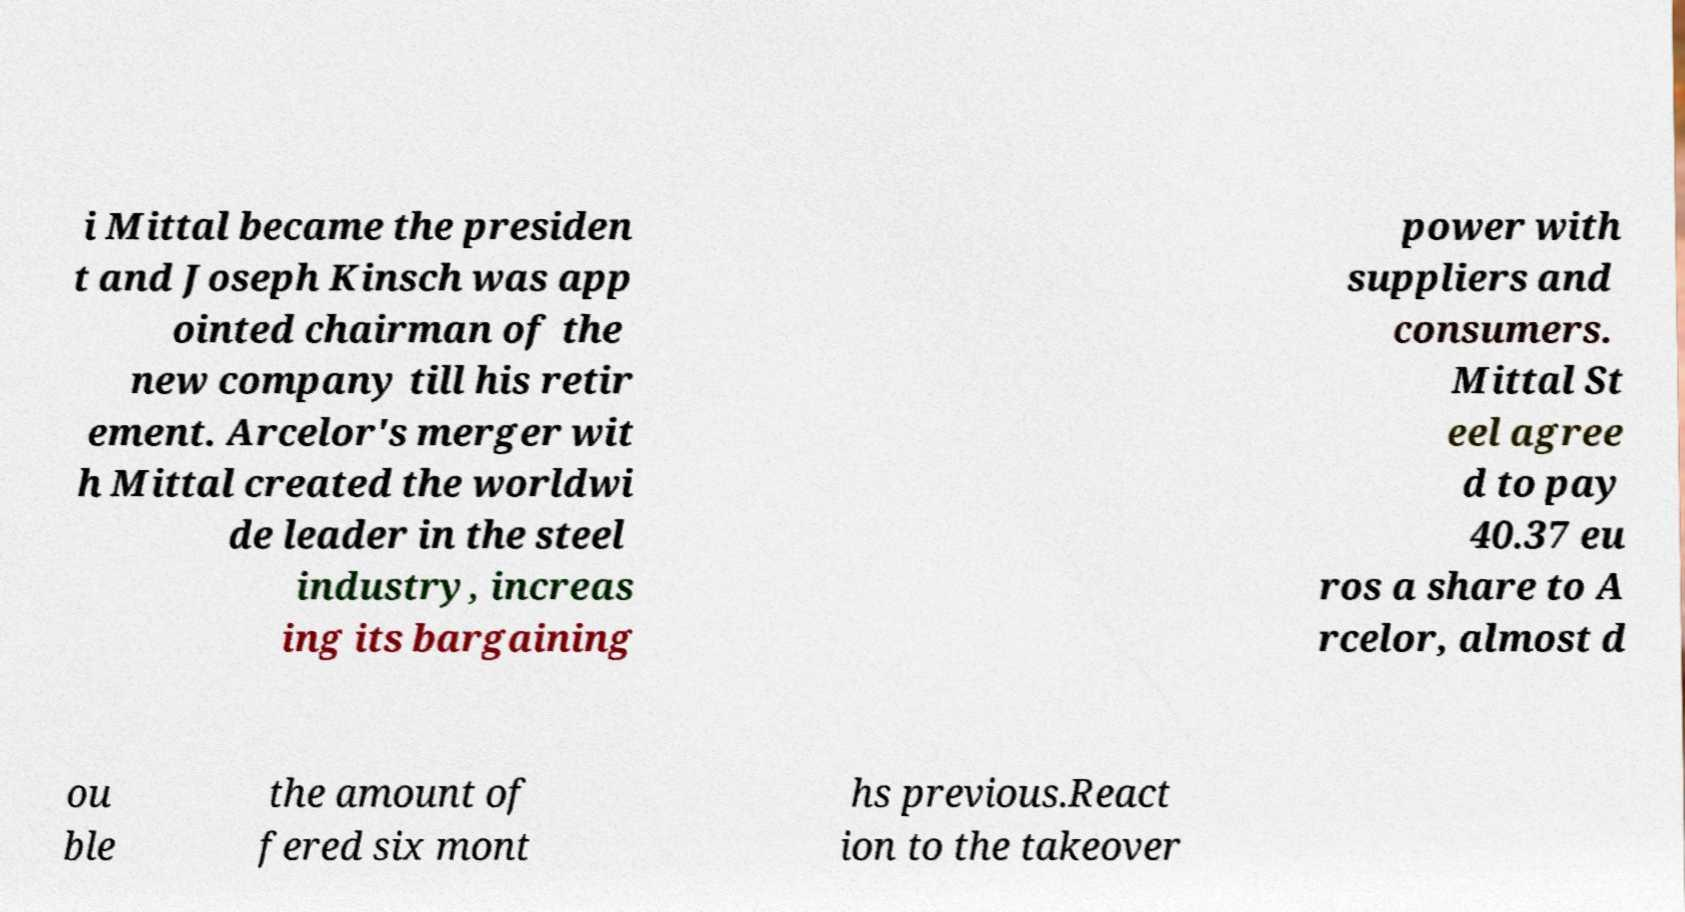Could you assist in decoding the text presented in this image and type it out clearly? i Mittal became the presiden t and Joseph Kinsch was app ointed chairman of the new company till his retir ement. Arcelor's merger wit h Mittal created the worldwi de leader in the steel industry, increas ing its bargaining power with suppliers and consumers. Mittal St eel agree d to pay 40.37 eu ros a share to A rcelor, almost d ou ble the amount of fered six mont hs previous.React ion to the takeover 